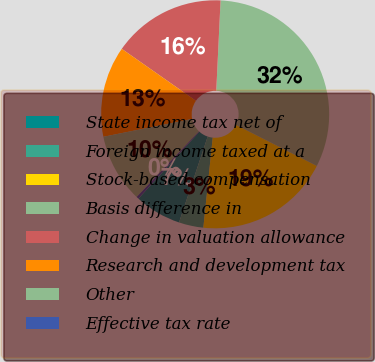<chart> <loc_0><loc_0><loc_500><loc_500><pie_chart><fcel>State income tax net of<fcel>Foreign income taxed at a<fcel>Stock-based compensation<fcel>Basis difference in<fcel>Change in valuation allowance<fcel>Research and development tax<fcel>Other<fcel>Effective tax rate<nl><fcel>6.62%<fcel>3.48%<fcel>19.17%<fcel>31.72%<fcel>16.03%<fcel>12.89%<fcel>9.75%<fcel>0.34%<nl></chart> 